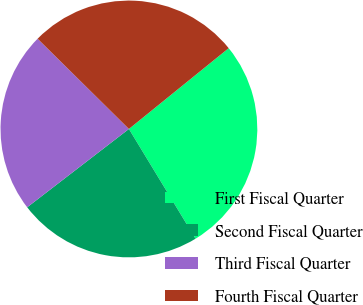Convert chart to OTSL. <chart><loc_0><loc_0><loc_500><loc_500><pie_chart><fcel>First Fiscal Quarter<fcel>Second Fiscal Quarter<fcel>Third Fiscal Quarter<fcel>Fourth Fiscal Quarter<nl><fcel>27.15%<fcel>23.24%<fcel>22.85%<fcel>26.76%<nl></chart> 